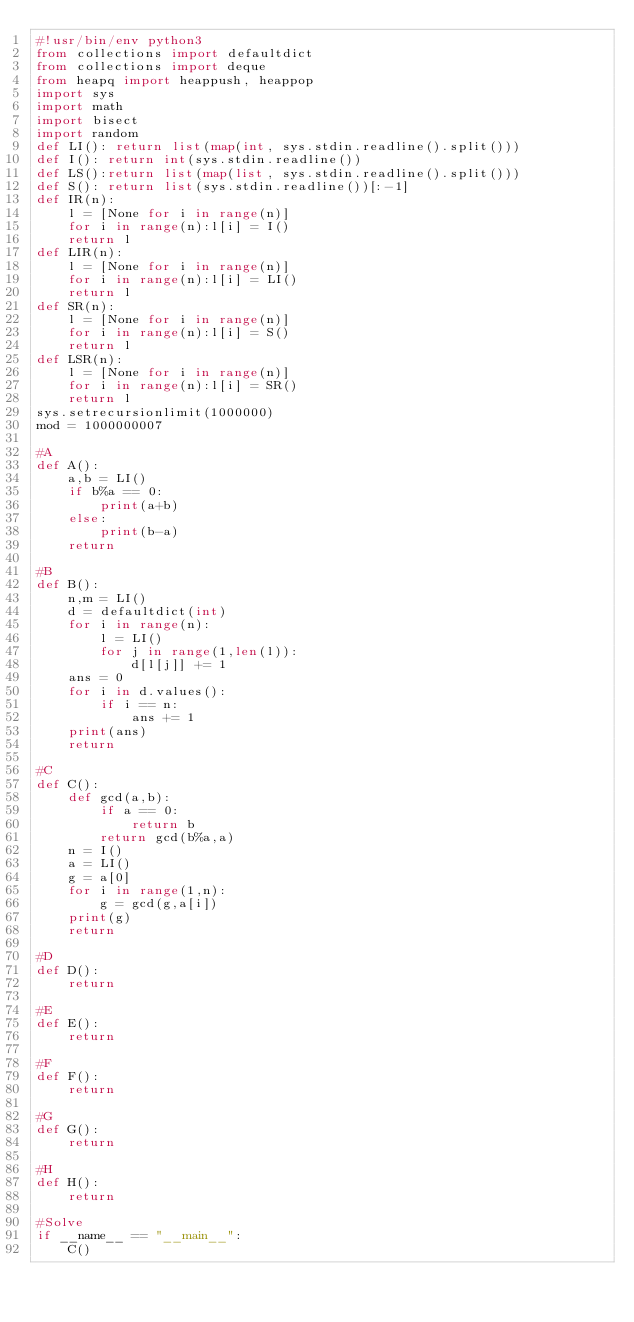<code> <loc_0><loc_0><loc_500><loc_500><_Python_>#!usr/bin/env python3
from collections import defaultdict
from collections import deque
from heapq import heappush, heappop
import sys
import math
import bisect
import random
def LI(): return list(map(int, sys.stdin.readline().split()))
def I(): return int(sys.stdin.readline())
def LS():return list(map(list, sys.stdin.readline().split()))
def S(): return list(sys.stdin.readline())[:-1]
def IR(n):
    l = [None for i in range(n)]
    for i in range(n):l[i] = I()
    return l
def LIR(n):
    l = [None for i in range(n)]
    for i in range(n):l[i] = LI()
    return l
def SR(n):
    l = [None for i in range(n)]
    for i in range(n):l[i] = S()
    return l
def LSR(n):
    l = [None for i in range(n)]
    for i in range(n):l[i] = SR()
    return l
sys.setrecursionlimit(1000000)
mod = 1000000007

#A
def A():
    a,b = LI()
    if b%a == 0:
        print(a+b)
    else:
        print(b-a)
    return

#B
def B():
    n,m = LI()
    d = defaultdict(int)
    for i in range(n):
        l = LI()
        for j in range(1,len(l)):
            d[l[j]] += 1
    ans = 0
    for i in d.values():
        if i == n:
            ans += 1
    print(ans)
    return

#C
def C():
    def gcd(a,b):
        if a == 0:
            return b
        return gcd(b%a,a)
    n = I()
    a = LI()
    g = a[0]
    for i in range(1,n):
        g = gcd(g,a[i])
    print(g)
    return

#D
def D():
    return

#E
def E():
    return

#F
def F():
    return

#G
def G():
    return

#H
def H():
    return

#Solve
if __name__ == "__main__":
    C()
</code> 